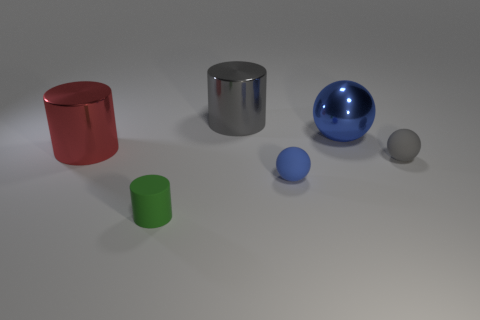Subtract all rubber balls. How many balls are left? 1 Add 4 small rubber spheres. How many objects exist? 10 Subtract 1 balls. How many balls are left? 2 Subtract 0 cyan spheres. How many objects are left? 6 Subtract all purple spheres. Subtract all yellow blocks. How many spheres are left? 3 Subtract all gray cubes. How many yellow cylinders are left? 0 Subtract all tiny rubber spheres. Subtract all cyan metallic objects. How many objects are left? 4 Add 3 red shiny cylinders. How many red shiny cylinders are left? 4 Add 1 big blue matte cubes. How many big blue matte cubes exist? 1 Subtract all red cylinders. How many cylinders are left? 2 